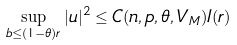Convert formula to latex. <formula><loc_0><loc_0><loc_500><loc_500>\sup _ { b \leq ( 1 - \theta ) r } | u | ^ { 2 } \leq C ( n , p , \theta , V _ { M } ) I ( r )</formula> 